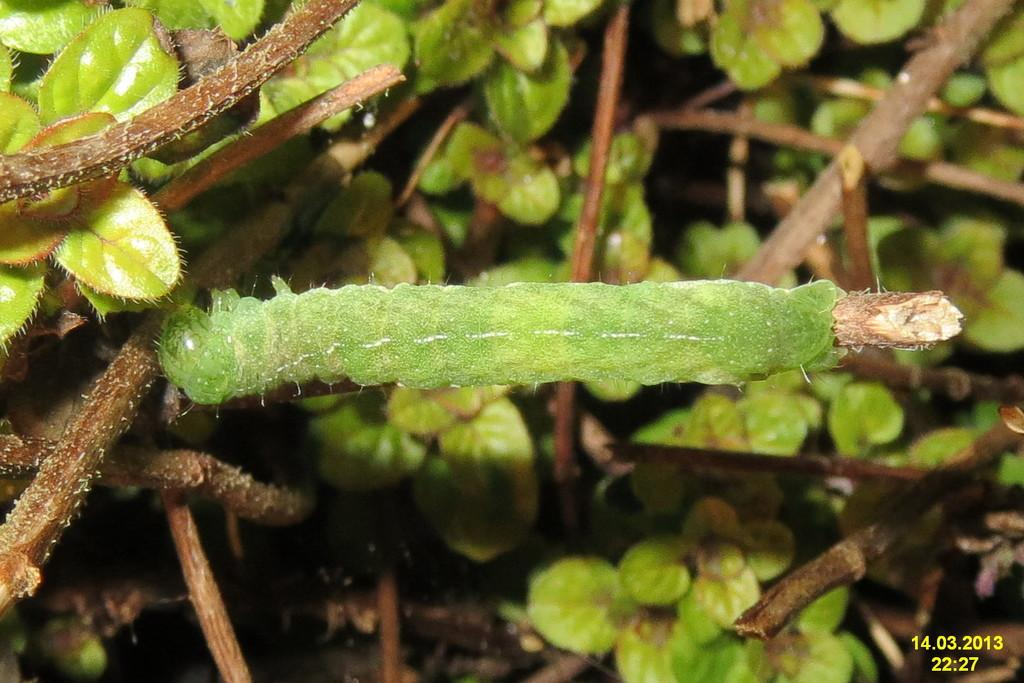What is the main subject of the image? There is a green insect on a stem in the image. Where can the numbers be found in the image? The numbers are in the right side bottom corner of the image. What type of vegetation is visible in the background of the image? There are plants with stems in the background of the image. What type of spoon is being used by the insect in the image? There is no spoon present in the image; it features a green insect on a stem. Can you describe the flight pattern of the insect in the image? The image is a still photograph, so there is no flight pattern to describe for the insect. 